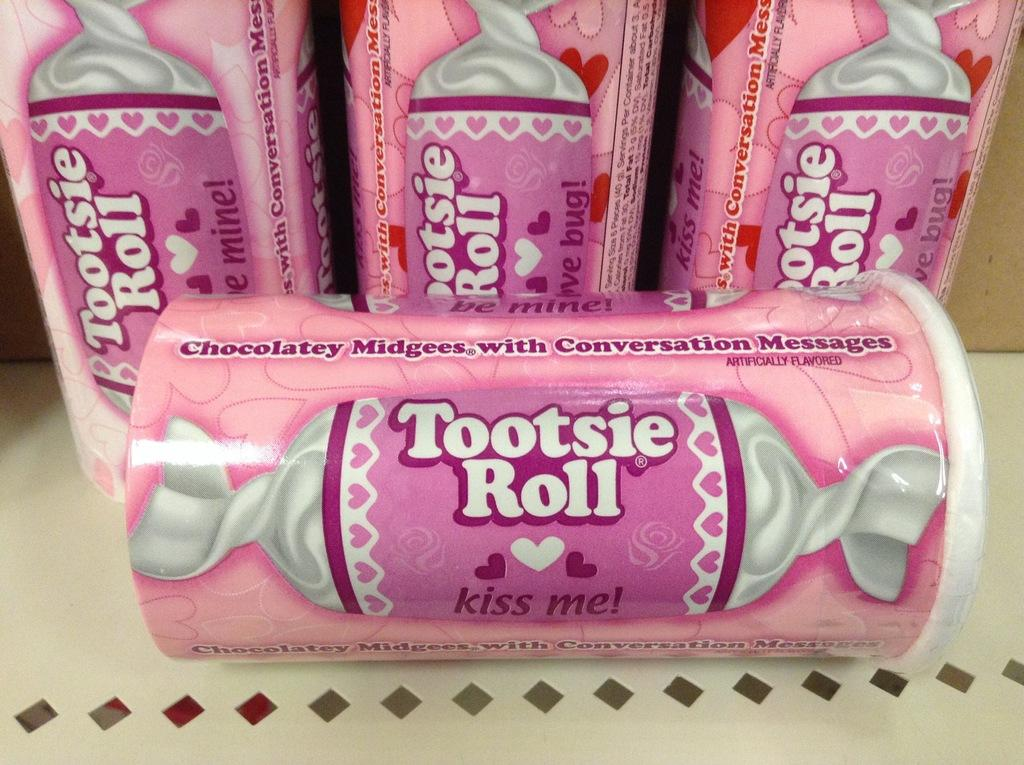What type of items are present in the image? There are chocolate boxes in the image. Where are the chocolate boxes located? The chocolate boxes are on a surface. How many sheep are participating in the competition in the image? There are no sheep or competition present in the image; it features chocolate boxes on a surface. What type of match is being played in the image? There is no match or any sports-related activity present in the image; it features chocolate boxes on a surface. 